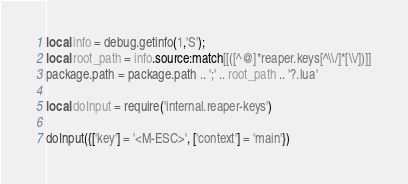Convert code to text. <code><loc_0><loc_0><loc_500><loc_500><_Lua_>
local info = debug.getinfo(1,'S');
local root_path = info.source:match[[([^@]*reaper.keys[^\\/]*[\\/])]]
package.path = package.path .. ';' .. root_path .. '?.lua'

local doInput = require('internal.reaper-keys')

doInput({['key'] = '<M-ESC>', ['context'] = 'main'})
</code> 